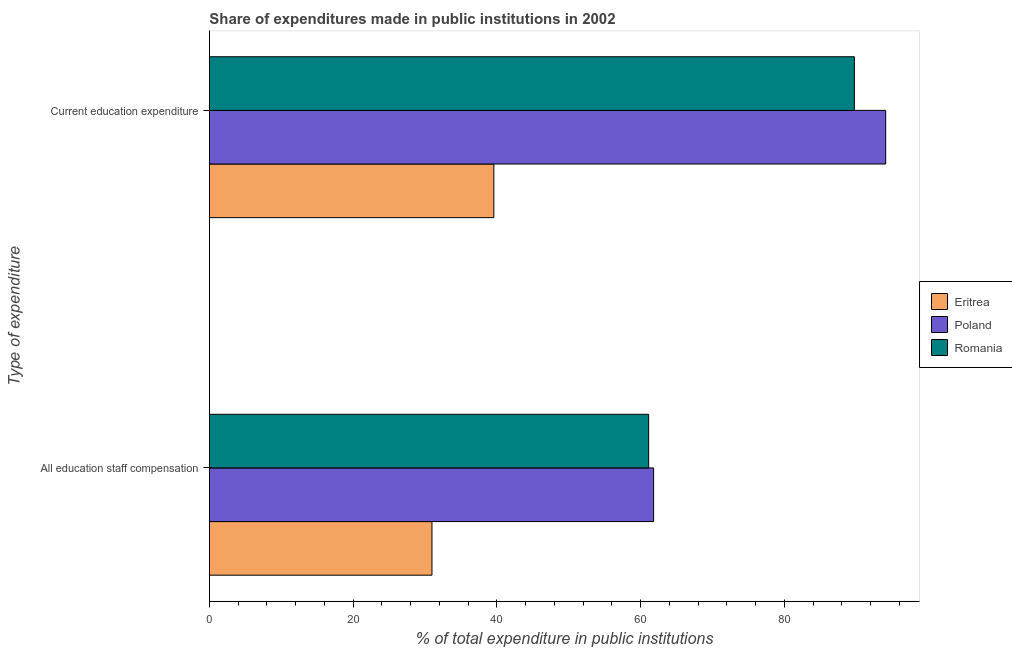How many different coloured bars are there?
Ensure brevity in your answer.  3. Are the number of bars per tick equal to the number of legend labels?
Ensure brevity in your answer.  Yes. How many bars are there on the 1st tick from the top?
Offer a very short reply. 3. How many bars are there on the 2nd tick from the bottom?
Your answer should be very brief. 3. What is the label of the 1st group of bars from the top?
Give a very brief answer. Current education expenditure. What is the expenditure in education in Poland?
Offer a very short reply. 94.11. Across all countries, what is the maximum expenditure in staff compensation?
Your response must be concise. 61.81. Across all countries, what is the minimum expenditure in staff compensation?
Your answer should be compact. 30.97. In which country was the expenditure in education minimum?
Offer a terse response. Eritrea. What is the total expenditure in education in the graph?
Provide a short and direct response. 223.44. What is the difference between the expenditure in staff compensation in Poland and that in Eritrea?
Ensure brevity in your answer.  30.84. What is the difference between the expenditure in education in Eritrea and the expenditure in staff compensation in Poland?
Provide a short and direct response. -22.23. What is the average expenditure in staff compensation per country?
Keep it short and to the point. 51.3. What is the difference between the expenditure in education and expenditure in staff compensation in Poland?
Provide a succinct answer. 32.3. In how many countries, is the expenditure in education greater than 60 %?
Offer a very short reply. 2. What is the ratio of the expenditure in education in Romania to that in Eritrea?
Give a very brief answer. 2.27. Is the expenditure in education in Romania less than that in Eritrea?
Your answer should be compact. No. In how many countries, is the expenditure in education greater than the average expenditure in education taken over all countries?
Make the answer very short. 2. What does the 2nd bar from the top in All education staff compensation represents?
Ensure brevity in your answer.  Poland. What does the 3rd bar from the bottom in All education staff compensation represents?
Offer a very short reply. Romania. Are all the bars in the graph horizontal?
Keep it short and to the point. Yes. Are the values on the major ticks of X-axis written in scientific E-notation?
Offer a terse response. No. Does the graph contain grids?
Make the answer very short. No. How many legend labels are there?
Your answer should be compact. 3. What is the title of the graph?
Offer a very short reply. Share of expenditures made in public institutions in 2002. What is the label or title of the X-axis?
Keep it short and to the point. % of total expenditure in public institutions. What is the label or title of the Y-axis?
Your answer should be compact. Type of expenditure. What is the % of total expenditure in public institutions in Eritrea in All education staff compensation?
Your response must be concise. 30.97. What is the % of total expenditure in public institutions of Poland in All education staff compensation?
Keep it short and to the point. 61.81. What is the % of total expenditure in public institutions of Romania in All education staff compensation?
Offer a terse response. 61.13. What is the % of total expenditure in public institutions in Eritrea in Current education expenditure?
Keep it short and to the point. 39.58. What is the % of total expenditure in public institutions of Poland in Current education expenditure?
Provide a succinct answer. 94.11. What is the % of total expenditure in public institutions in Romania in Current education expenditure?
Your answer should be very brief. 89.75. Across all Type of expenditure, what is the maximum % of total expenditure in public institutions in Eritrea?
Provide a short and direct response. 39.58. Across all Type of expenditure, what is the maximum % of total expenditure in public institutions of Poland?
Provide a succinct answer. 94.11. Across all Type of expenditure, what is the maximum % of total expenditure in public institutions in Romania?
Provide a succinct answer. 89.75. Across all Type of expenditure, what is the minimum % of total expenditure in public institutions in Eritrea?
Make the answer very short. 30.97. Across all Type of expenditure, what is the minimum % of total expenditure in public institutions in Poland?
Ensure brevity in your answer.  61.81. Across all Type of expenditure, what is the minimum % of total expenditure in public institutions in Romania?
Your response must be concise. 61.13. What is the total % of total expenditure in public institutions of Eritrea in the graph?
Ensure brevity in your answer.  70.55. What is the total % of total expenditure in public institutions of Poland in the graph?
Make the answer very short. 155.93. What is the total % of total expenditure in public institutions in Romania in the graph?
Your answer should be very brief. 150.88. What is the difference between the % of total expenditure in public institutions in Eritrea in All education staff compensation and that in Current education expenditure?
Keep it short and to the point. -8.61. What is the difference between the % of total expenditure in public institutions of Poland in All education staff compensation and that in Current education expenditure?
Offer a very short reply. -32.3. What is the difference between the % of total expenditure in public institutions in Romania in All education staff compensation and that in Current education expenditure?
Offer a very short reply. -28.62. What is the difference between the % of total expenditure in public institutions of Eritrea in All education staff compensation and the % of total expenditure in public institutions of Poland in Current education expenditure?
Offer a very short reply. -63.14. What is the difference between the % of total expenditure in public institutions in Eritrea in All education staff compensation and the % of total expenditure in public institutions in Romania in Current education expenditure?
Your answer should be very brief. -58.78. What is the difference between the % of total expenditure in public institutions of Poland in All education staff compensation and the % of total expenditure in public institutions of Romania in Current education expenditure?
Ensure brevity in your answer.  -27.94. What is the average % of total expenditure in public institutions in Eritrea per Type of expenditure?
Offer a very short reply. 35.28. What is the average % of total expenditure in public institutions in Poland per Type of expenditure?
Offer a terse response. 77.96. What is the average % of total expenditure in public institutions in Romania per Type of expenditure?
Ensure brevity in your answer.  75.44. What is the difference between the % of total expenditure in public institutions of Eritrea and % of total expenditure in public institutions of Poland in All education staff compensation?
Provide a succinct answer. -30.84. What is the difference between the % of total expenditure in public institutions in Eritrea and % of total expenditure in public institutions in Romania in All education staff compensation?
Ensure brevity in your answer.  -30.15. What is the difference between the % of total expenditure in public institutions of Poland and % of total expenditure in public institutions of Romania in All education staff compensation?
Give a very brief answer. 0.69. What is the difference between the % of total expenditure in public institutions of Eritrea and % of total expenditure in public institutions of Poland in Current education expenditure?
Offer a very short reply. -54.53. What is the difference between the % of total expenditure in public institutions in Eritrea and % of total expenditure in public institutions in Romania in Current education expenditure?
Provide a succinct answer. -50.17. What is the difference between the % of total expenditure in public institutions in Poland and % of total expenditure in public institutions in Romania in Current education expenditure?
Offer a terse response. 4.36. What is the ratio of the % of total expenditure in public institutions of Eritrea in All education staff compensation to that in Current education expenditure?
Provide a succinct answer. 0.78. What is the ratio of the % of total expenditure in public institutions in Poland in All education staff compensation to that in Current education expenditure?
Ensure brevity in your answer.  0.66. What is the ratio of the % of total expenditure in public institutions of Romania in All education staff compensation to that in Current education expenditure?
Your answer should be compact. 0.68. What is the difference between the highest and the second highest % of total expenditure in public institutions of Eritrea?
Your response must be concise. 8.61. What is the difference between the highest and the second highest % of total expenditure in public institutions of Poland?
Your response must be concise. 32.3. What is the difference between the highest and the second highest % of total expenditure in public institutions of Romania?
Provide a short and direct response. 28.62. What is the difference between the highest and the lowest % of total expenditure in public institutions of Eritrea?
Ensure brevity in your answer.  8.61. What is the difference between the highest and the lowest % of total expenditure in public institutions in Poland?
Keep it short and to the point. 32.3. What is the difference between the highest and the lowest % of total expenditure in public institutions of Romania?
Offer a very short reply. 28.62. 